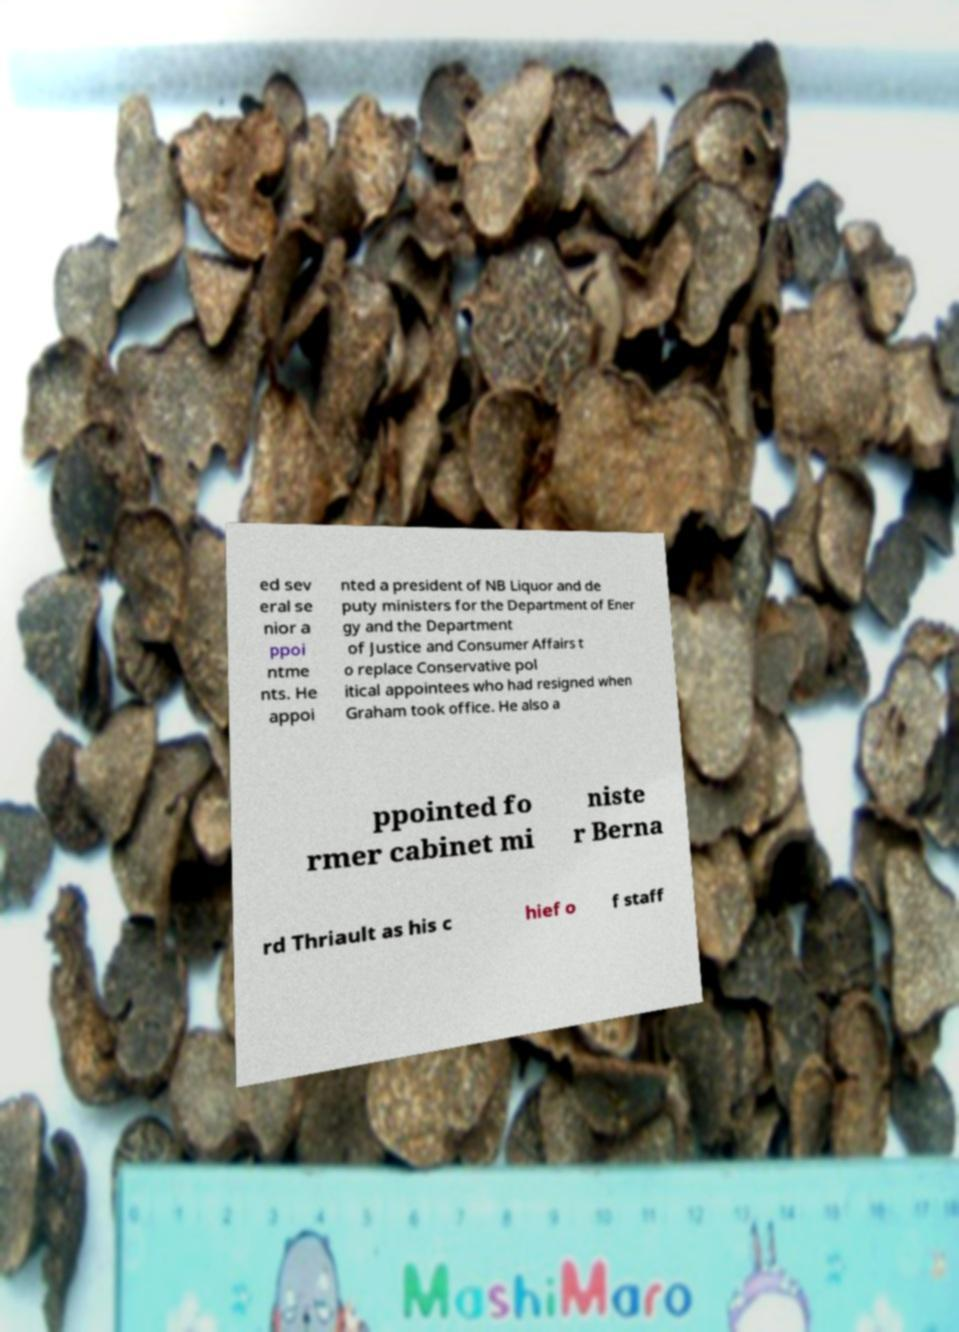Please read and relay the text visible in this image. What does it say? ed sev eral se nior a ppoi ntme nts. He appoi nted a president of NB Liquor and de puty ministers for the Department of Ener gy and the Department of Justice and Consumer Affairs t o replace Conservative pol itical appointees who had resigned when Graham took office. He also a ppointed fo rmer cabinet mi niste r Berna rd Thriault as his c hief o f staff 